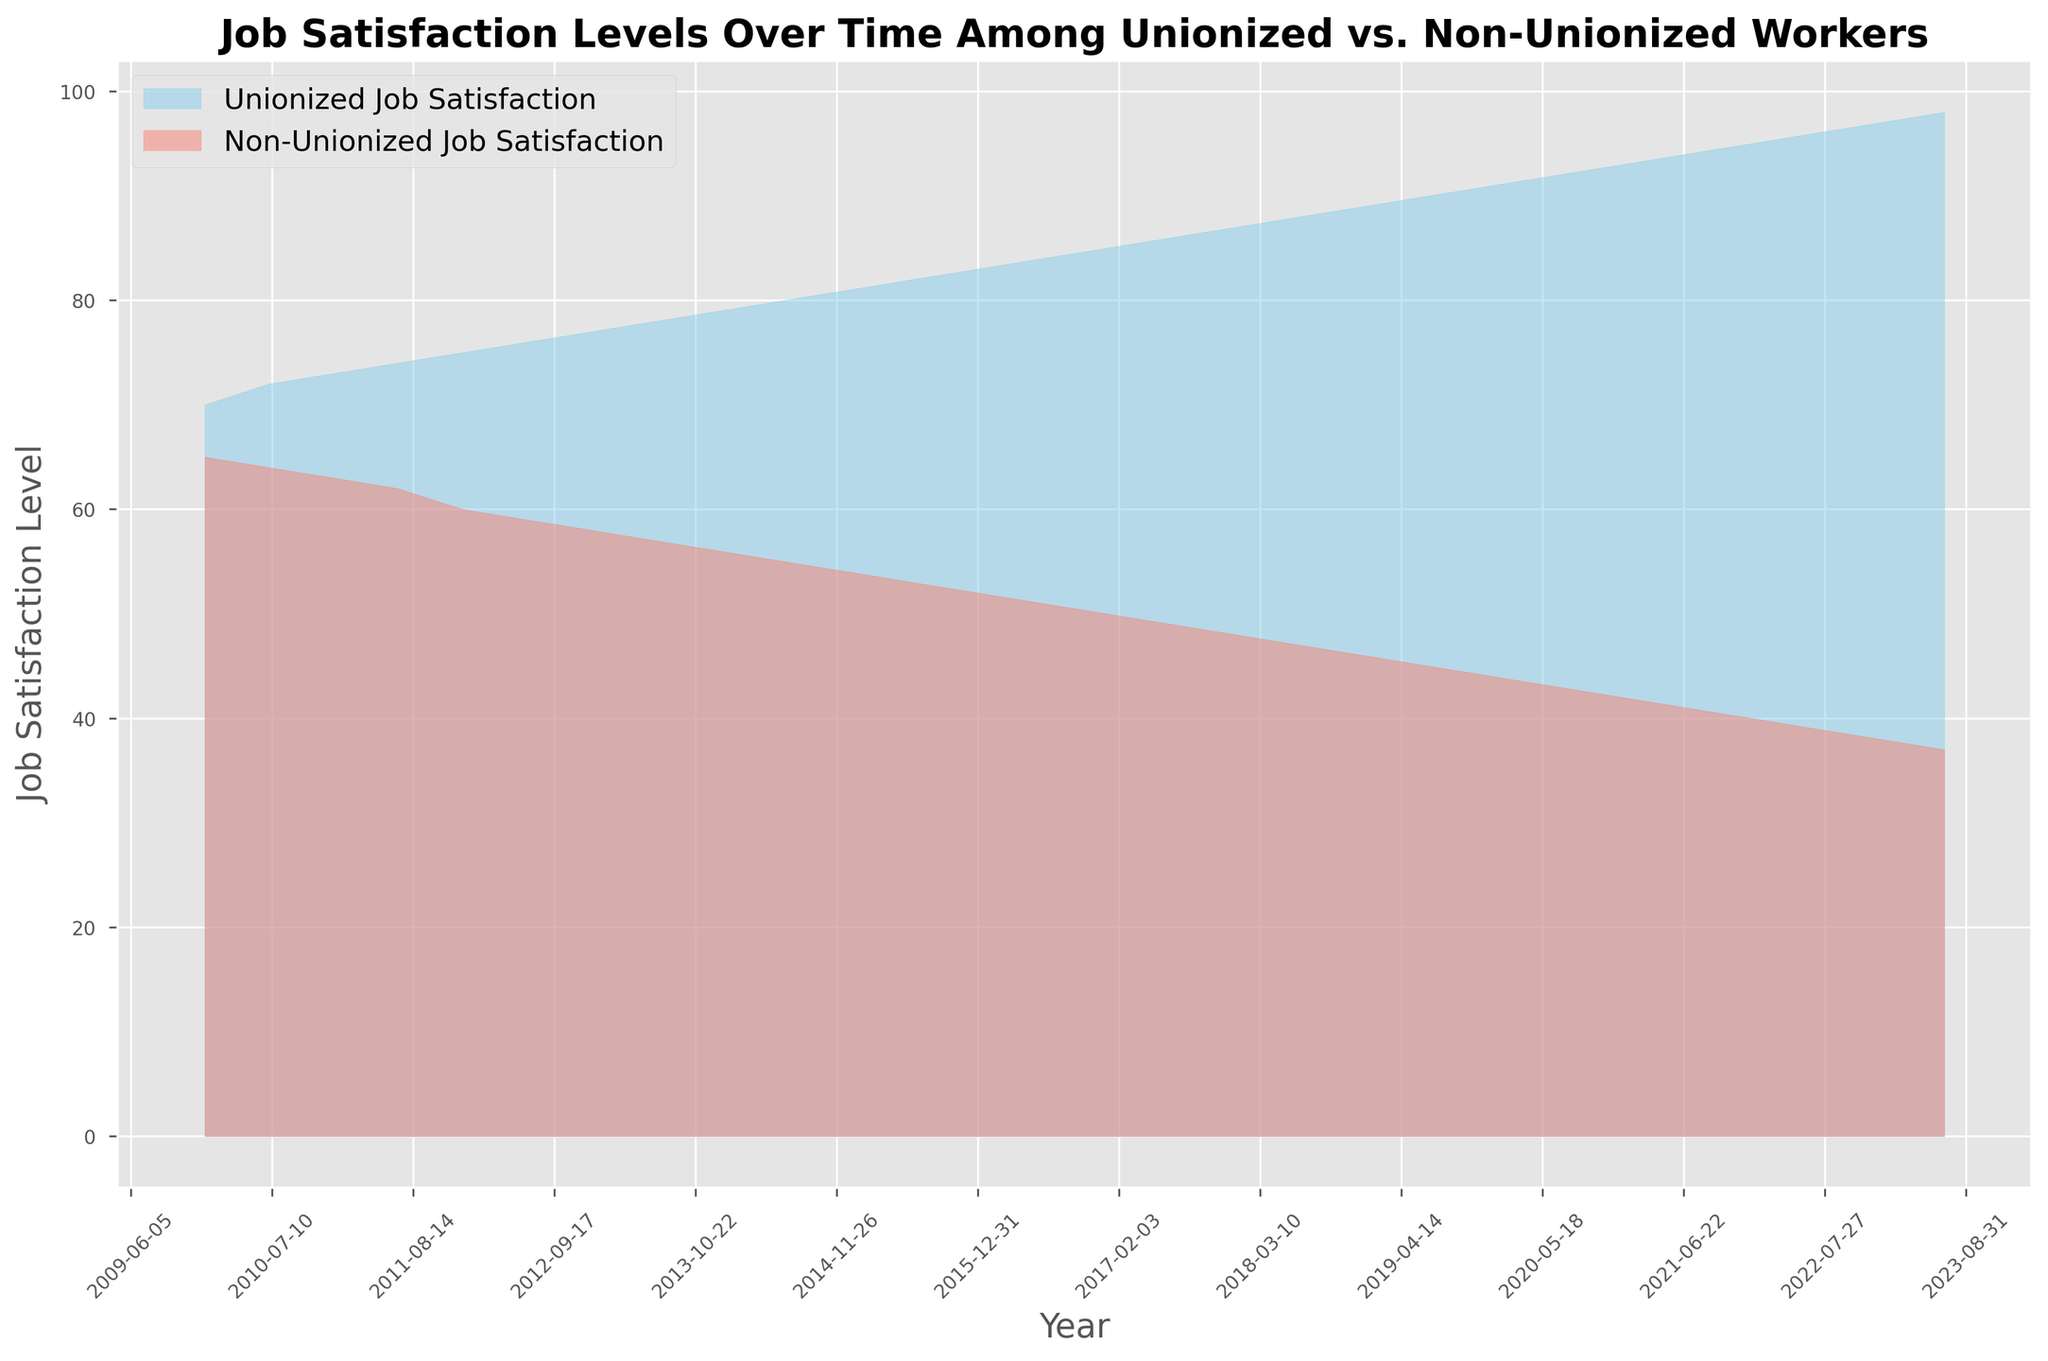Which group shows a higher job satisfaction level in 2013? Compare the heights of the filled areas for unionized and non-unionized groups in 2013 from the chart. The blue area (unionized) is higher.
Answer: Unionized group How does the job satisfaction level of unionized workers in 2017 compare to the non-unionized workers in 2017? Look at the 2017 data points on the x-axis and compare the heights of the filled areas for unionized (blue) and non-unionized (red). Unionized workers have higher satisfaction.
Answer: Higher What is the job satisfaction level trend for non-unionized workers from 2010 to 2023? Observe the red area from left (2010) to right (2023). The job satisfaction level steadily declines.
Answer: Declining trend In which year did unionized workers reach a job satisfaction level of 90? Identify the point on the blue area that reaches the level of 90 on the y-axis and correlate it with the x-axis (year). This occurs around 2019.
Answer: 2019 By how much did the job satisfaction level of unionized workers increase from 2015 to 2020? Find the job satisfaction levels for unionized workers in 2015 (81) and 2020 (92) and calculate the difference: 92 - 81 = 11.
Answer: 11 points What is the difference in job satisfaction levels between unionized and non-unionized workers in 2023? Look at the job satisfaction levels for both groups in 2023 and subtract the non-unionized level (37) from the unionized level (98): 98 - 37 = 61.
Answer: 61 points Which year marks the first time the job satisfaction level of non-unionized workers fell below 50? Observe the red area and find the point where it first drops below the 50 level on the y-axis. This occurs around 2017.
Answer: 2017 What color represents unionized workers' job satisfaction in the chart? Identify the color of the filled area labeled as unionized workers' job satisfaction.
Answer: Blue Between which two years did unionized workers see the largest increase in job satisfaction level? Compare the differences in unionized job satisfaction levels between consecutive years and identify the largest increment. The largest increase is between 2022 (95) and 2023 (97 or 98).
Answer: 2022 and 2023 How does the slope of job satisfaction levels from 2010 to 2023 compare for unionized vs. non-unionized workers? Observe the steepness of the blue and red areas over the entire time span. The blue area (unionized) shows a positive (upward) slope, and the red area (non-unionized) shows a negative (downward) slope.
Answer: Unionized: upward, Non-unionized: downward 